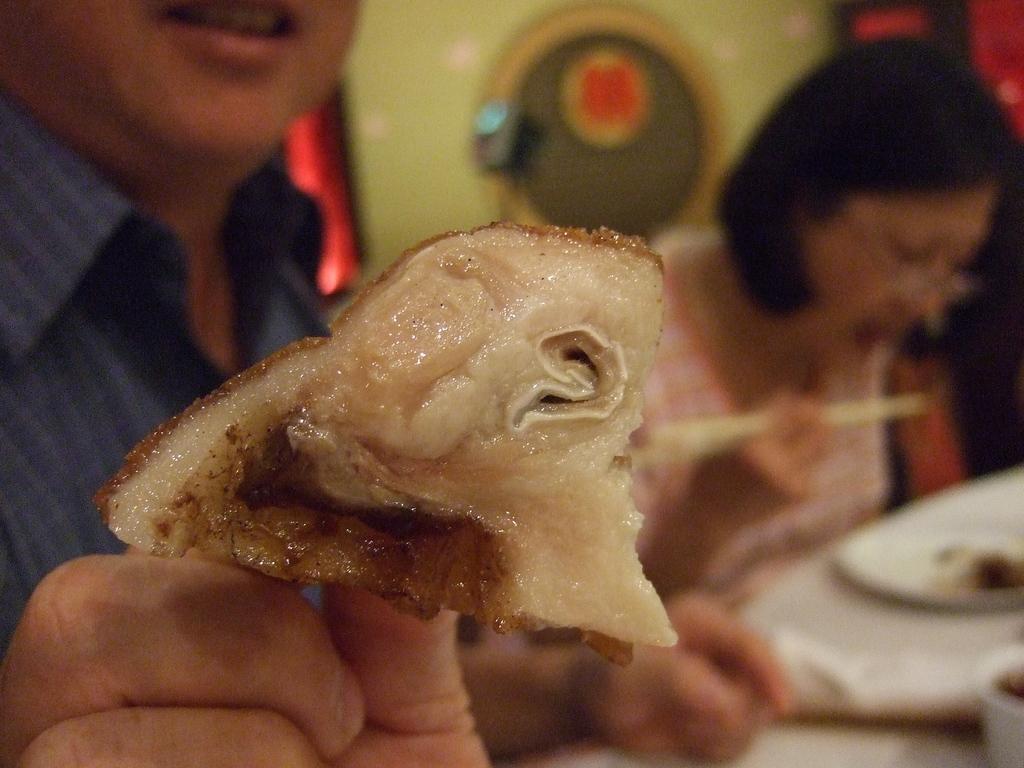Could you give a brief overview of what you see in this image? On the left side, there is a person in a shirt, holding a food item with a hand and sitting in front of the table on which, there are some objects. Beside him, there is a woman. In the background, there is an object. 